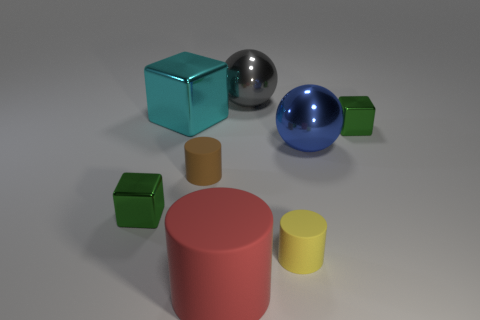Are there any big red cylinders that have the same material as the brown object?
Your answer should be compact. Yes. What is the tiny cylinder that is to the left of the red thing made of?
Your response must be concise. Rubber. What material is the yellow object?
Provide a short and direct response. Rubber. Is the material of the tiny green cube on the left side of the cyan object the same as the red thing?
Keep it short and to the point. No. Is the number of small green metal blocks that are to the left of the big cube less than the number of large green rubber objects?
Provide a short and direct response. No. The matte thing that is the same size as the yellow rubber cylinder is what color?
Keep it short and to the point. Brown. What number of big rubber things are the same shape as the big gray shiny thing?
Make the answer very short. 0. The tiny rubber object that is right of the big red rubber cylinder is what color?
Your response must be concise. Yellow. What number of shiny objects are large gray objects or balls?
Make the answer very short. 2. How many red objects have the same size as the yellow thing?
Ensure brevity in your answer.  0. 